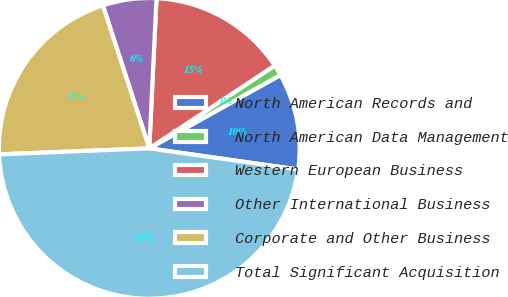<chart> <loc_0><loc_0><loc_500><loc_500><pie_chart><fcel>North American Records and<fcel>North American Data Management<fcel>Western European Business<fcel>Other International Business<fcel>Corporate and Other Business<fcel>Total Significant Acquisition<nl><fcel>10.36%<fcel>1.17%<fcel>14.95%<fcel>5.76%<fcel>20.64%<fcel>47.13%<nl></chart> 